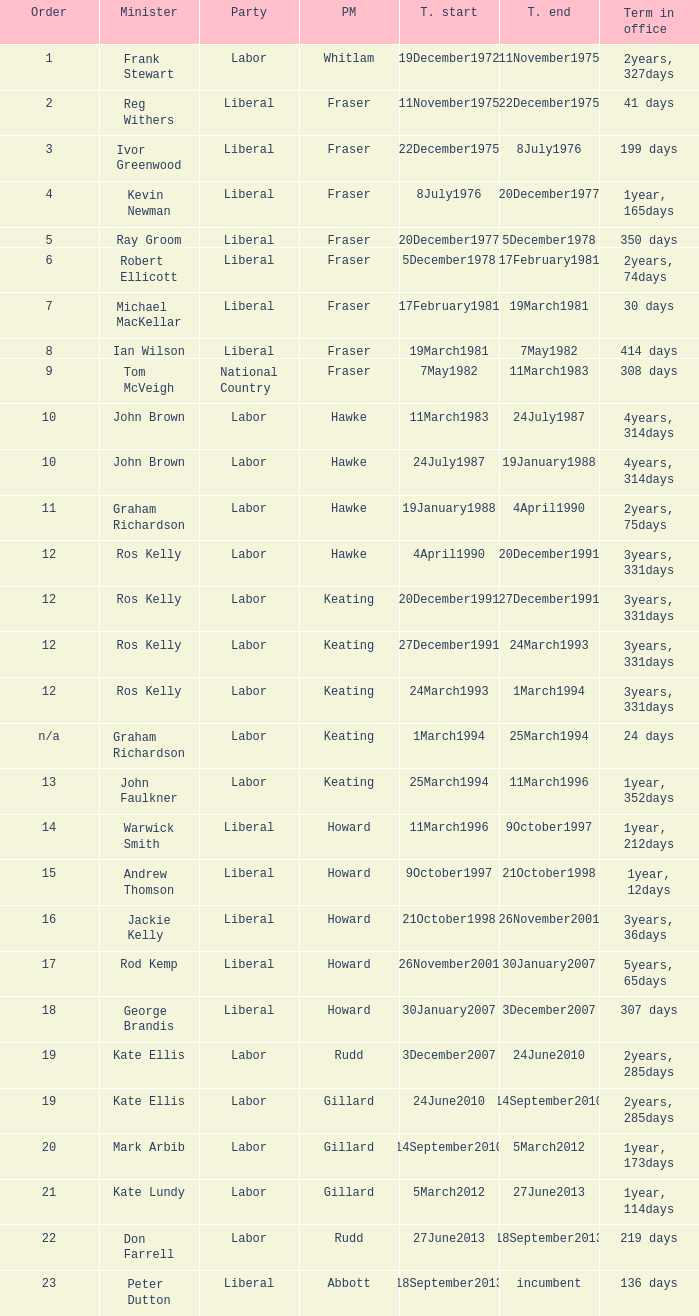What is the Term in office with an Order that is 9? 308 days. 